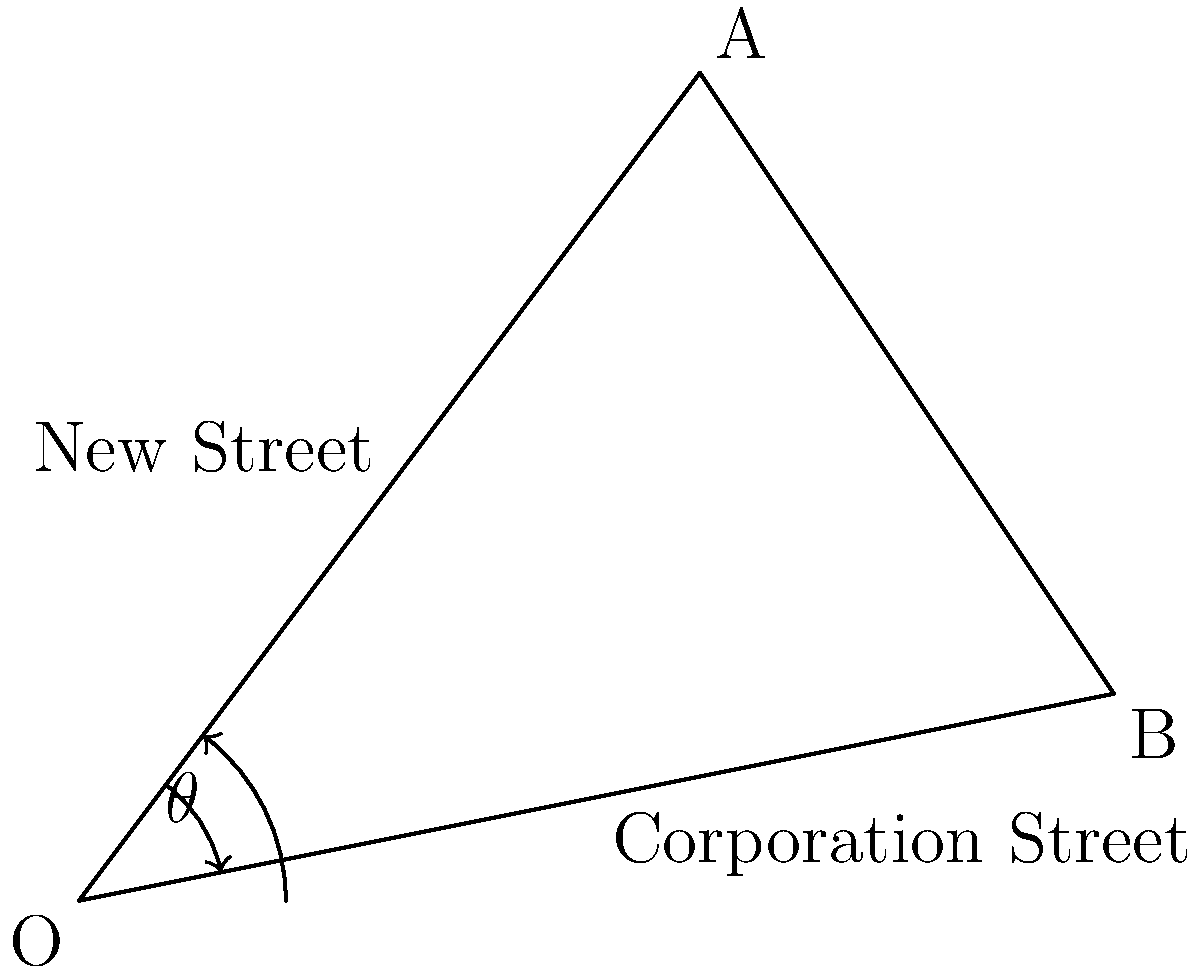In Birmingham's city center, New Street and Corporation Street intersect at a point O. If New Street runs in the direction of vector $\vec{a} = 3\hat{i} + 4\hat{j}$ and Corporation Street runs in the direction of vector $\vec{b} = 5\hat{i} + \hat{j}$, what is the angle $\theta$ between these two streets? To find the angle between two vectors using the dot product, we can follow these steps:

1) The dot product formula for the angle between two vectors is:

   $$\cos \theta = \frac{\vec{a} \cdot \vec{b}}{|\vec{a}||\vec{b}|}$$

2) Calculate the dot product $\vec{a} \cdot \vec{b}$:
   $$\vec{a} \cdot \vec{b} = (3)(5) + (4)(1) = 15 + 4 = 19$$

3) Calculate the magnitudes of the vectors:
   $$|\vec{a}| = \sqrt{3^2 + 4^2} = \sqrt{9 + 16} = \sqrt{25} = 5$$
   $$|\vec{b}| = \sqrt{5^2 + 1^2} = \sqrt{25 + 1} = \sqrt{26}$$

4) Substitute into the formula:
   $$\cos \theta = \frac{19}{5\sqrt{26}}$$

5) Take the inverse cosine (arccos) of both sides:
   $$\theta = \arccos(\frac{19}{5\sqrt{26}})$$

6) Calculate the result:
   $$\theta \approx 0.5365 \text{ radians} \approx 30.74°$$

Therefore, the angle between New Street and Corporation Street is approximately 30.74°.
Answer: $30.74°$ 